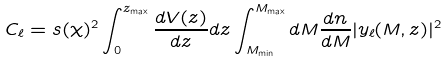<formula> <loc_0><loc_0><loc_500><loc_500>C _ { \ell } = s ( \chi ) ^ { 2 } \int _ { 0 } ^ { z _ { \max } } \frac { d V ( z ) } { d z } d z \int _ { M _ { \min } } ^ { M _ { \max } } { d M \frac { d n } { d M } | y _ { \ell } ( M , z ) | ^ { 2 } }</formula> 